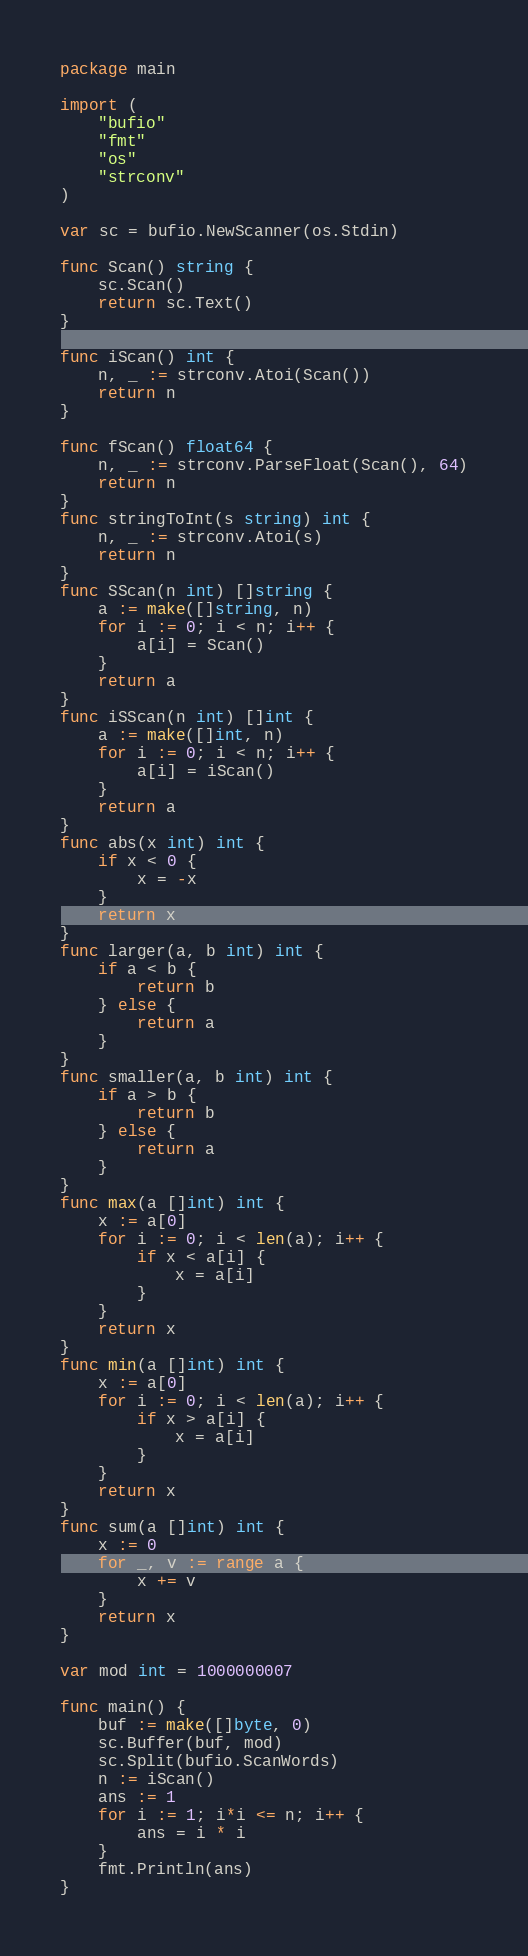<code> <loc_0><loc_0><loc_500><loc_500><_Go_>package main

import (
	"bufio"
	"fmt"
	"os"
	"strconv"
)

var sc = bufio.NewScanner(os.Stdin)

func Scan() string {
	sc.Scan()
	return sc.Text()
}

func iScan() int {
	n, _ := strconv.Atoi(Scan())
	return n
}

func fScan() float64 {
	n, _ := strconv.ParseFloat(Scan(), 64)
	return n
}
func stringToInt(s string) int {
	n, _ := strconv.Atoi(s)
	return n
}
func SScan(n int) []string {
	a := make([]string, n)
	for i := 0; i < n; i++ {
		a[i] = Scan()
	}
	return a
}
func iSScan(n int) []int {
	a := make([]int, n)
	for i := 0; i < n; i++ {
		a[i] = iScan()
	}
	return a
}
func abs(x int) int {
	if x < 0 {
		x = -x
	}
	return x
}
func larger(a, b int) int {
	if a < b {
		return b
	} else {
		return a
	}
}
func smaller(a, b int) int {
	if a > b {
		return b
	} else {
		return a
	}
}
func max(a []int) int {
	x := a[0]
	for i := 0; i < len(a); i++ {
		if x < a[i] {
			x = a[i]
		}
	}
	return x
}
func min(a []int) int {
	x := a[0]
	for i := 0; i < len(a); i++ {
		if x > a[i] {
			x = a[i]
		}
	}
	return x
}
func sum(a []int) int {
	x := 0
	for _, v := range a {
		x += v
	}
	return x
}

var mod int = 1000000007

func main() {
	buf := make([]byte, 0)
	sc.Buffer(buf, mod)
	sc.Split(bufio.ScanWords)
	n := iScan()
	ans := 1
	for i := 1; i*i <= n; i++ {
		ans = i * i
	}
	fmt.Println(ans)
}
</code> 